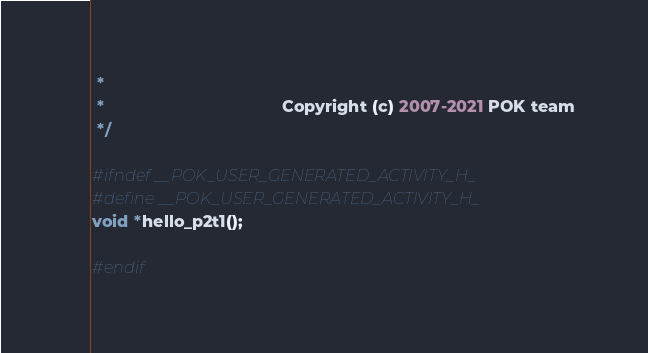Convert code to text. <code><loc_0><loc_0><loc_500><loc_500><_C_> *
 *                                      Copyright (c) 2007-2021 POK team
 */

#ifndef __POK_USER_GENERATED_ACTIVITY_H_
#define __POK_USER_GENERATED_ACTIVITY_H_
void *hello_p2t1();

#endif
</code> 